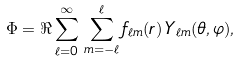<formula> <loc_0><loc_0><loc_500><loc_500>\Phi = \Re \sum _ { \ell = 0 } ^ { \infty } \, \sum _ { m = - \ell } ^ { \ell } f _ { \ell m } ( r ) \, Y _ { \ell m } ( \theta , \varphi ) ,</formula> 